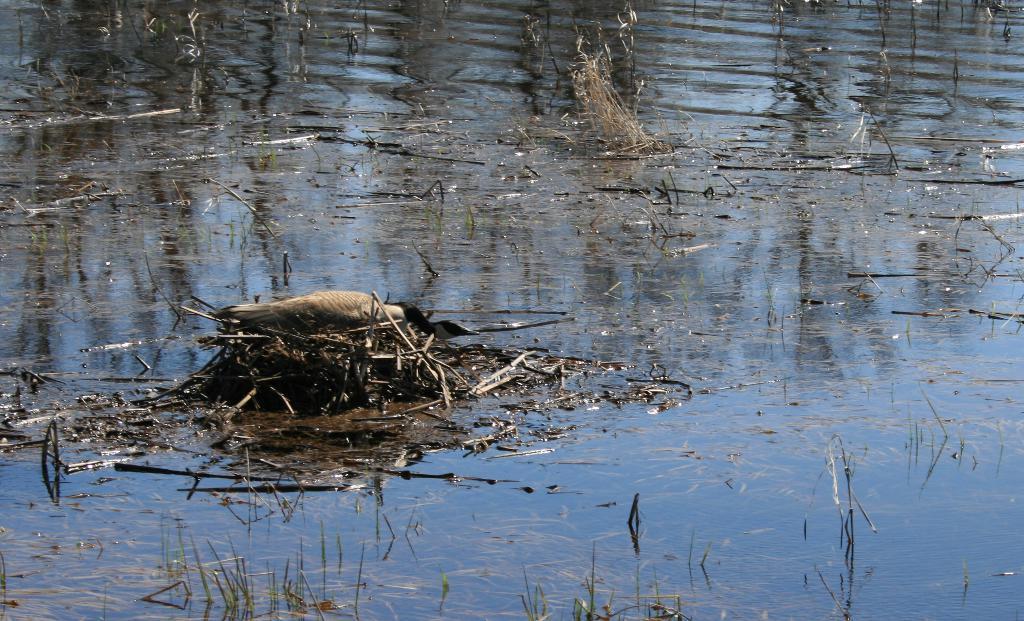Can you describe this image briefly? In this picture, we see a bird. At the bottom of the picture, we see water and this water might be in the pond. We even see the grass and the twigs. 